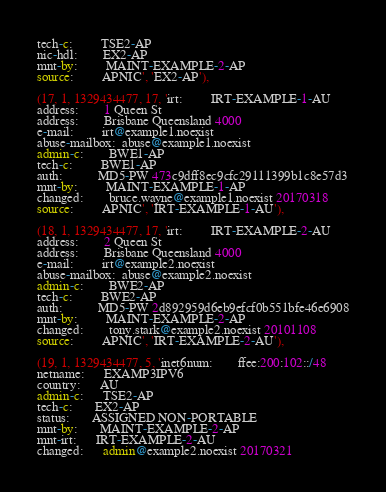<code> <loc_0><loc_0><loc_500><loc_500><_SQL_>tech-c:         TSE2-AP
nic-hdl:        EX2-AP
mnt-by:         MAINT-EXAMPLE-2-AP
source:         APNIC', 'EX2-AP'),

(17, 1, 1329434477, 17, 'irt:         IRT-EXAMPLE-1-AU
address:        1 Queen St
address:        Brisbane Queensland 4000
e-mail:         irt@example1.noexist
abuse-mailbox:  abuse@example1.noexist
admin-c:        BWE1-AP
tech-c:         BWE1-AP
auth:           MD5-PW 473c9dff8ec9cfc29111399b1c8e57d3
mnt-by:         MAINT-EXAMPLE-1-AP
changed:        bruce.wayne@example1.noexist 20170318
source:         APNIC', 'IRT-EXAMPLE-1-AU'),

(18, 1, 1329434477, 17, 'irt:         IRT-EXAMPLE-2-AU
address:        2 Queen St
address:        Brisbane Queensland 4000
e-mail:         irt@example2.noexist
abuse-mailbox:  abuse@example2.noexist
admin-c:        BWE2-AP
tech-c:         BWE2-AP
auth:           MD5-PW 2d892959d6eb9efcf0b551bfe46e6908
mnt-by:         MAINT-EXAMPLE-2-AP
changed:        tony.stark@example2.noexist 20101108
source:         APNIC', 'IRT-EXAMPLE-2-AU'),

(19, 1, 1329434477, 5, 'inet6num:        ffee:200:102::/48
netname:      EXAMP3IPV6
country:      AU
admin-c:      TSE2-AP
tech-c:       EX2-AP
status:       ASSIGNED NON-PORTABLE
mnt-by:       MAINT-EXAMPLE-2-AP
mnt-irt:      IRT-EXAMPLE-2-AU
changed:      admin@example2.noexist 20170321</code> 